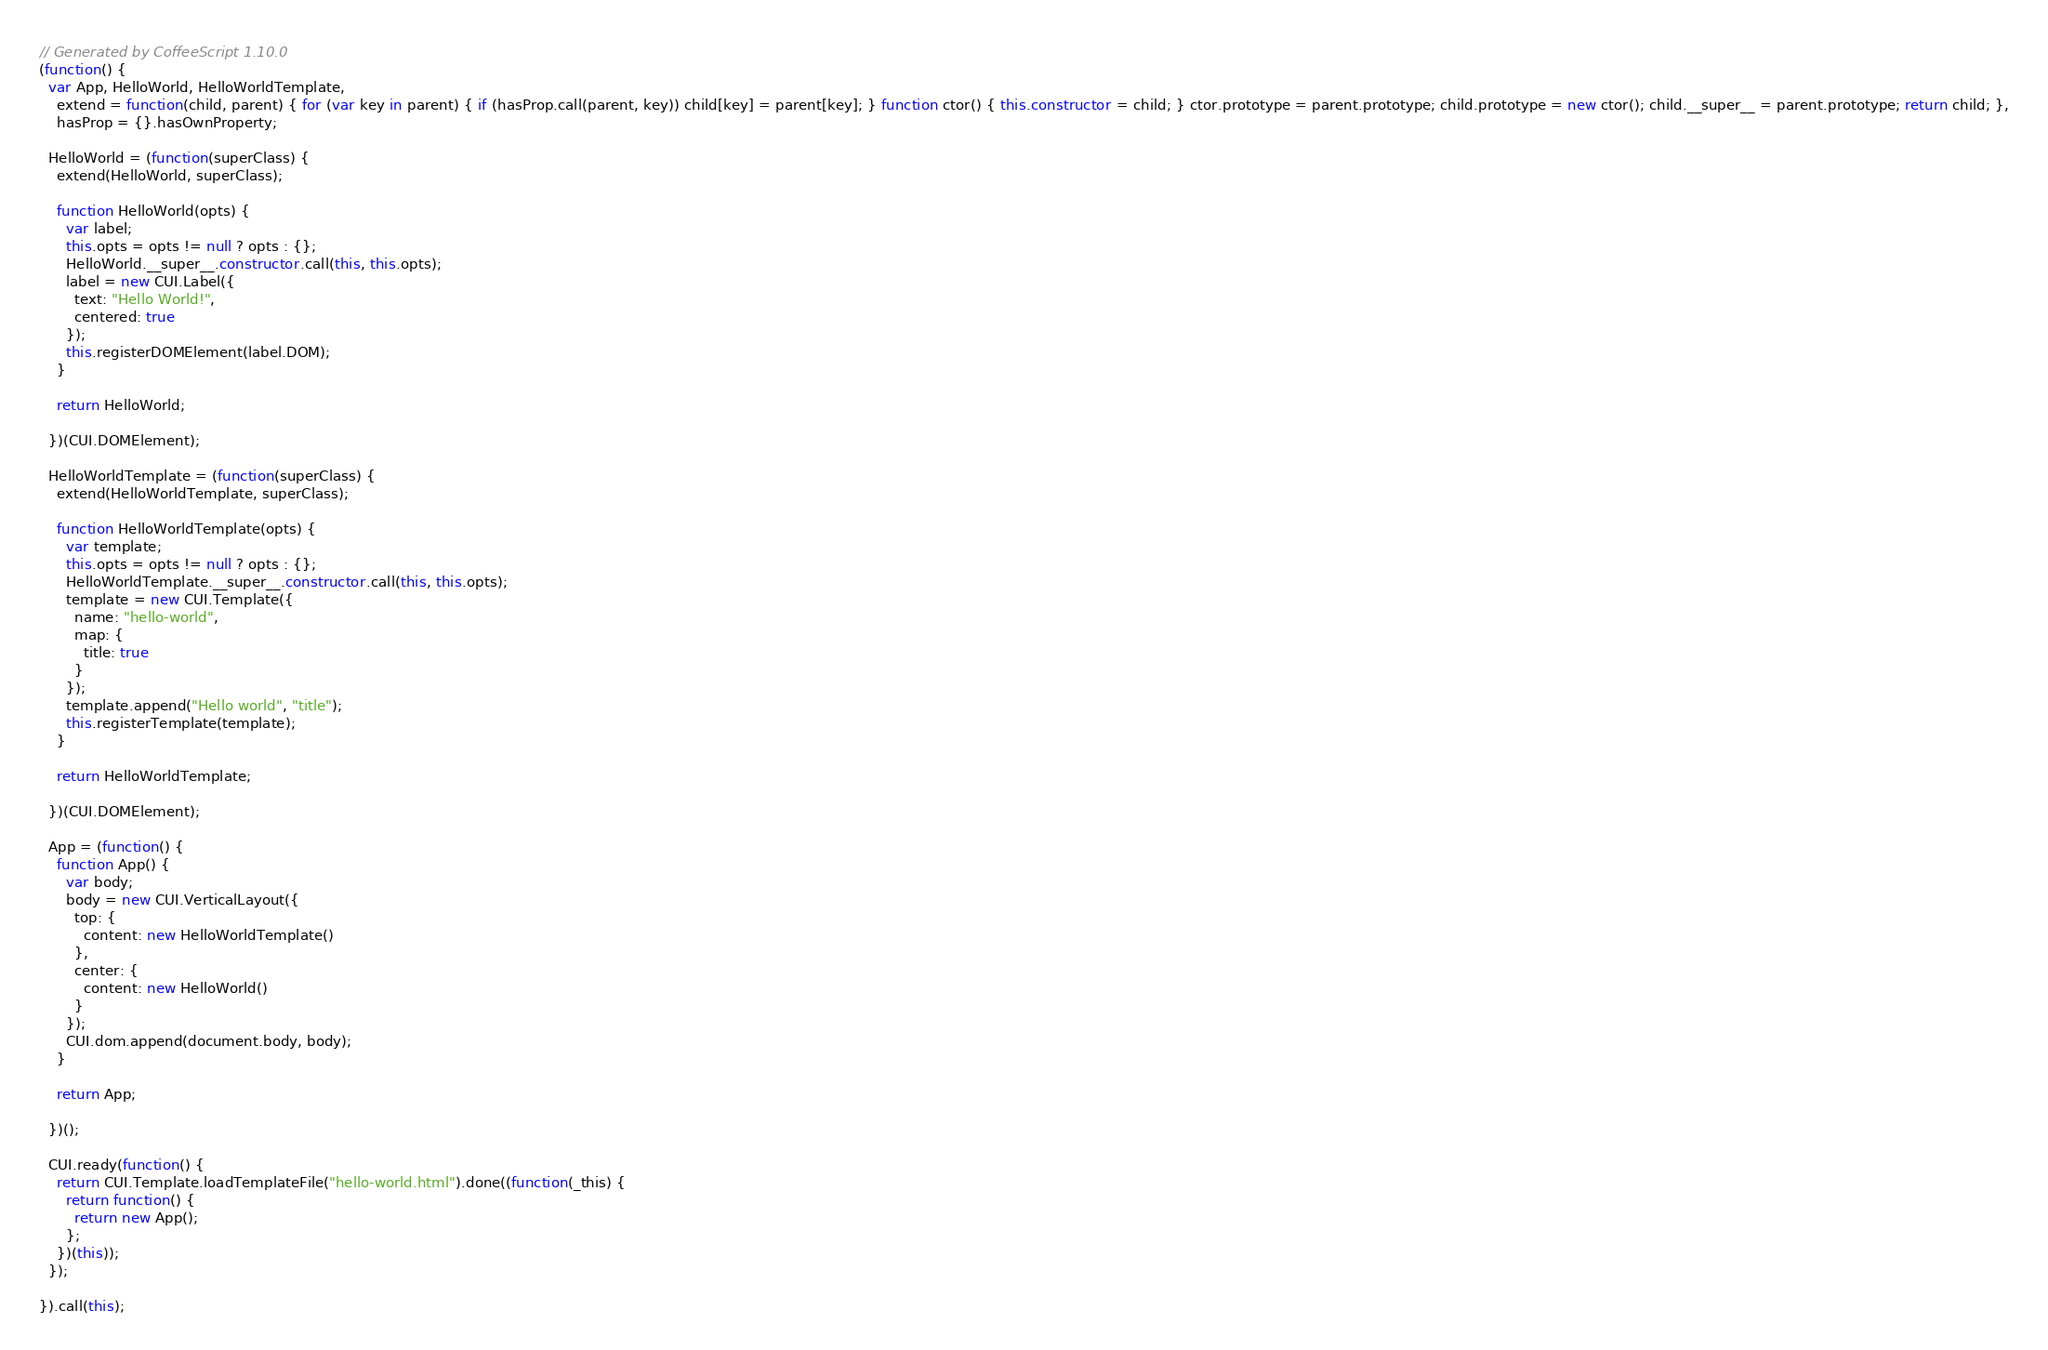Convert code to text. <code><loc_0><loc_0><loc_500><loc_500><_JavaScript_>// Generated by CoffeeScript 1.10.0
(function() {
  var App, HelloWorld, HelloWorldTemplate,
    extend = function(child, parent) { for (var key in parent) { if (hasProp.call(parent, key)) child[key] = parent[key]; } function ctor() { this.constructor = child; } ctor.prototype = parent.prototype; child.prototype = new ctor(); child.__super__ = parent.prototype; return child; },
    hasProp = {}.hasOwnProperty;

  HelloWorld = (function(superClass) {
    extend(HelloWorld, superClass);

    function HelloWorld(opts) {
      var label;
      this.opts = opts != null ? opts : {};
      HelloWorld.__super__.constructor.call(this, this.opts);
      label = new CUI.Label({
        text: "Hello World!",
        centered: true
      });
      this.registerDOMElement(label.DOM);
    }

    return HelloWorld;

  })(CUI.DOMElement);

  HelloWorldTemplate = (function(superClass) {
    extend(HelloWorldTemplate, superClass);

    function HelloWorldTemplate(opts) {
      var template;
      this.opts = opts != null ? opts : {};
      HelloWorldTemplate.__super__.constructor.call(this, this.opts);
      template = new CUI.Template({
        name: "hello-world",
        map: {
          title: true
        }
      });
      template.append("Hello world", "title");
      this.registerTemplate(template);
    }

    return HelloWorldTemplate;

  })(CUI.DOMElement);

  App = (function() {
    function App() {
      var body;
      body = new CUI.VerticalLayout({
        top: {
          content: new HelloWorldTemplate()
        },
        center: {
          content: new HelloWorld()
        }
      });
      CUI.dom.append(document.body, body);
    }

    return App;

  })();

  CUI.ready(function() {
    return CUI.Template.loadTemplateFile("hello-world.html").done((function(_this) {
      return function() {
        return new App();
      };
    })(this));
  });

}).call(this);
</code> 